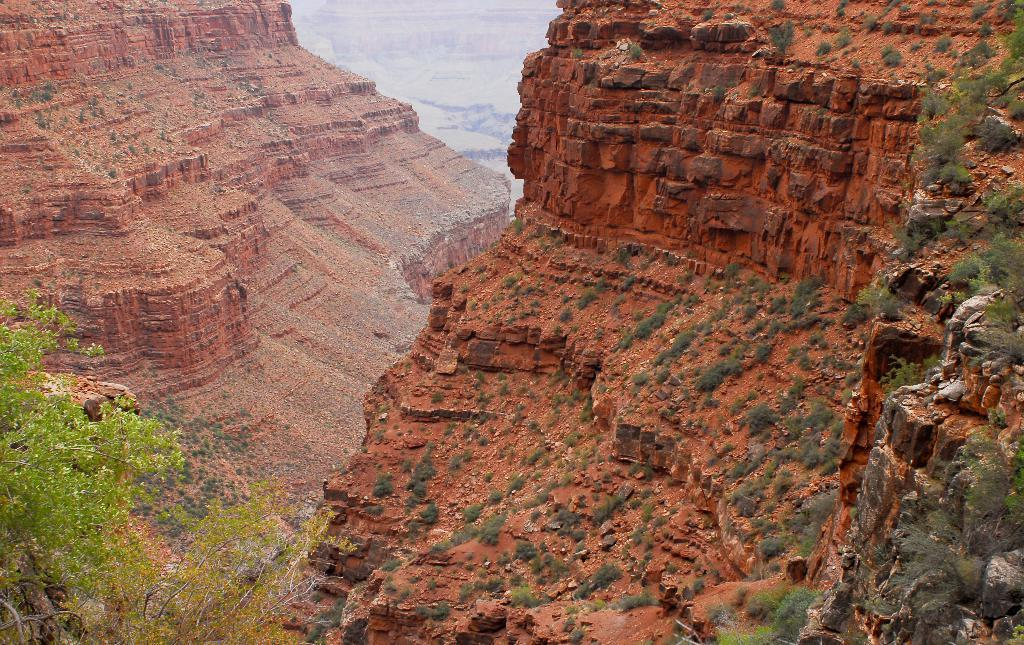What type of landscape is depicted in the image? The image features hills. What type of vegetation can be seen in the image? There is grass visible in the image. Where is the tree located in the image? The tree is at the left bottom of the image. What type of plant is growing in the downtown area in the image? There is no downtown area present in the image, and therefore no plants growing in it. 